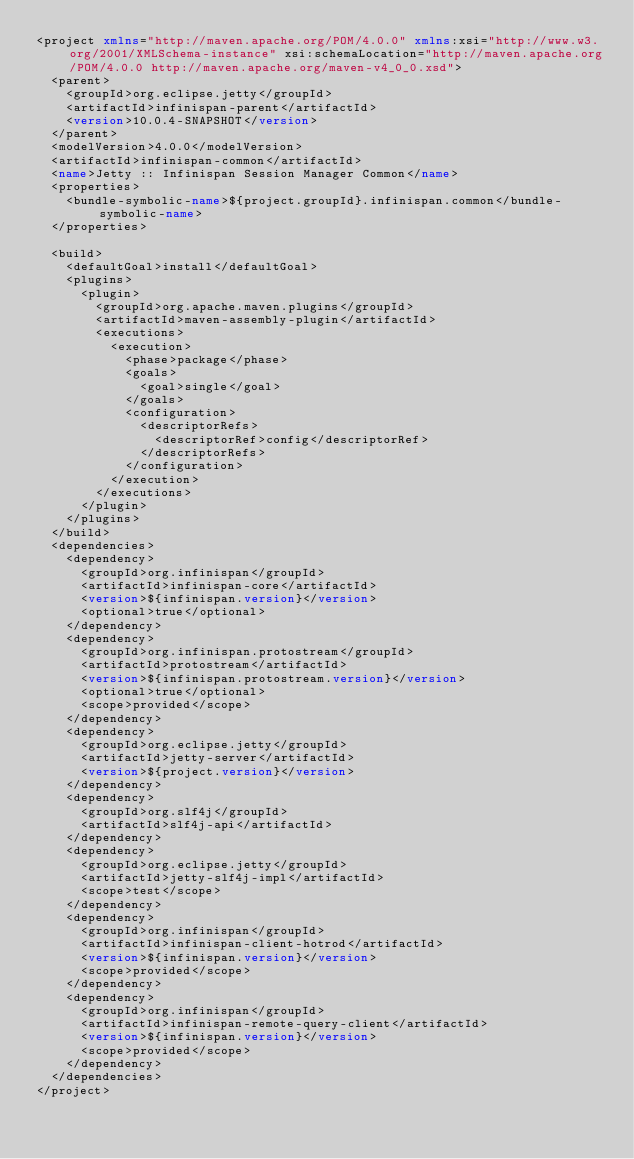Convert code to text. <code><loc_0><loc_0><loc_500><loc_500><_XML_><project xmlns="http://maven.apache.org/POM/4.0.0" xmlns:xsi="http://www.w3.org/2001/XMLSchema-instance" xsi:schemaLocation="http://maven.apache.org/POM/4.0.0 http://maven.apache.org/maven-v4_0_0.xsd">
  <parent>
    <groupId>org.eclipse.jetty</groupId>
    <artifactId>infinispan-parent</artifactId>
    <version>10.0.4-SNAPSHOT</version>
  </parent>
  <modelVersion>4.0.0</modelVersion>
  <artifactId>infinispan-common</artifactId>
  <name>Jetty :: Infinispan Session Manager Common</name>
  <properties>
    <bundle-symbolic-name>${project.groupId}.infinispan.common</bundle-symbolic-name>
  </properties>

  <build>
    <defaultGoal>install</defaultGoal>
    <plugins>
      <plugin>
        <groupId>org.apache.maven.plugins</groupId>
        <artifactId>maven-assembly-plugin</artifactId>
        <executions>
          <execution>
            <phase>package</phase>
            <goals>
              <goal>single</goal>
            </goals>
            <configuration>
              <descriptorRefs>
                <descriptorRef>config</descriptorRef>
              </descriptorRefs>
            </configuration>
          </execution>
        </executions>
      </plugin>
    </plugins>
  </build>
  <dependencies>
    <dependency>
      <groupId>org.infinispan</groupId>
      <artifactId>infinispan-core</artifactId>
      <version>${infinispan.version}</version>
      <optional>true</optional>
    </dependency>
    <dependency>
      <groupId>org.infinispan.protostream</groupId>
      <artifactId>protostream</artifactId>
      <version>${infinispan.protostream.version}</version>
      <optional>true</optional>
      <scope>provided</scope>
    </dependency>
    <dependency>
      <groupId>org.eclipse.jetty</groupId>
      <artifactId>jetty-server</artifactId>
      <version>${project.version}</version>
    </dependency>
    <dependency>
      <groupId>org.slf4j</groupId>
      <artifactId>slf4j-api</artifactId>
    </dependency>
    <dependency>
      <groupId>org.eclipse.jetty</groupId>
      <artifactId>jetty-slf4j-impl</artifactId>
      <scope>test</scope>
    </dependency>
    <dependency>
      <groupId>org.infinispan</groupId>
      <artifactId>infinispan-client-hotrod</artifactId>
      <version>${infinispan.version}</version>
      <scope>provided</scope>
    </dependency>
    <dependency>
      <groupId>org.infinispan</groupId>
      <artifactId>infinispan-remote-query-client</artifactId>
      <version>${infinispan.version}</version>
      <scope>provided</scope>
    </dependency>
  </dependencies>
</project>
</code> 